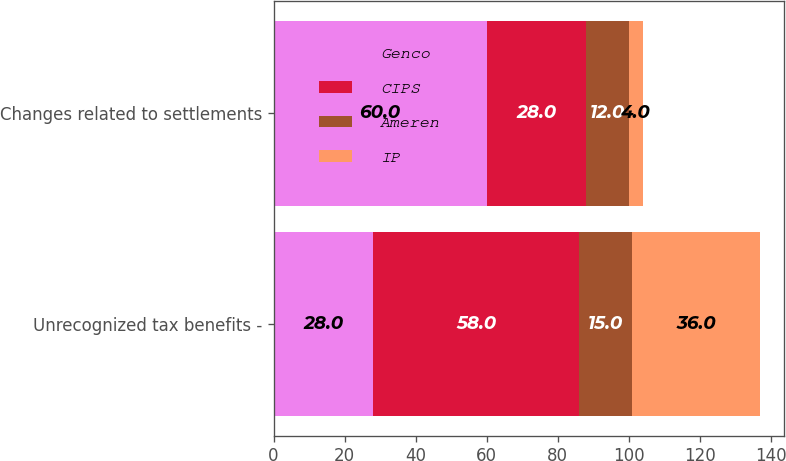Convert chart to OTSL. <chart><loc_0><loc_0><loc_500><loc_500><stacked_bar_chart><ecel><fcel>Unrecognized tax benefits -<fcel>Changes related to settlements<nl><fcel>Genco<fcel>28<fcel>60<nl><fcel>CIPS<fcel>58<fcel>28<nl><fcel>Ameren<fcel>15<fcel>12<nl><fcel>IP<fcel>36<fcel>4<nl></chart> 